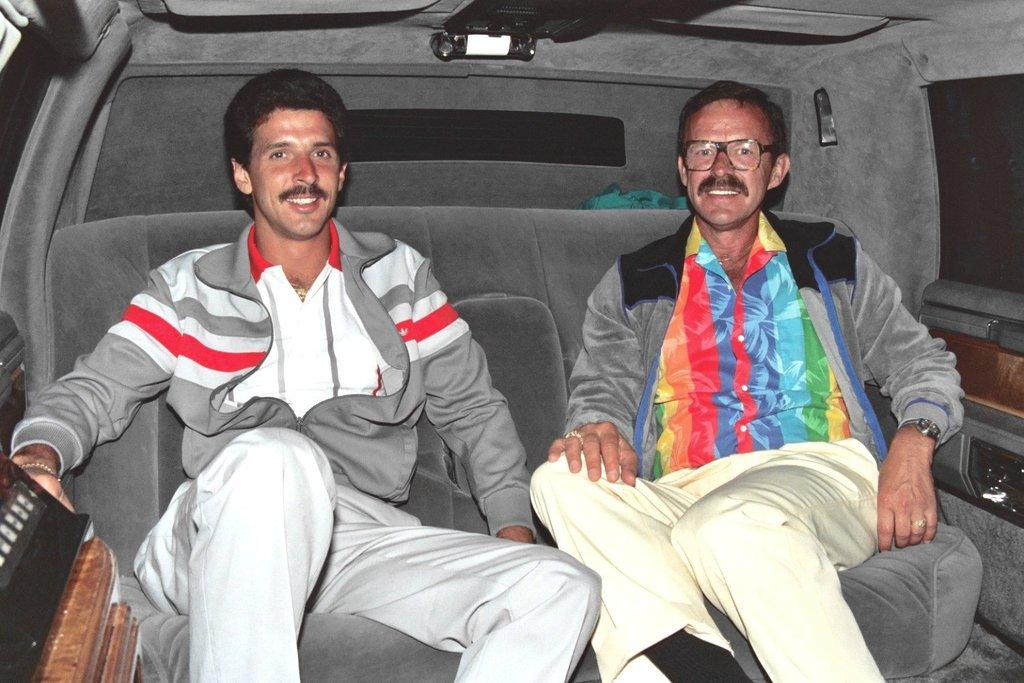What is the main subject of the image? The main subject of the image is men. What are the men doing in the image? The men are sitting on a sofa. Are the men in a specific location in the image? Yes, the men are in a car. What are the men wearing in the image? The men are wearing jackets. Can you see any signs of a kiss between the men in the image? There is no indication of a kiss between the men in the image. What type of shock can be seen affecting the men in the image? There is no shock or any indication of a shock affecting the men in the image. 